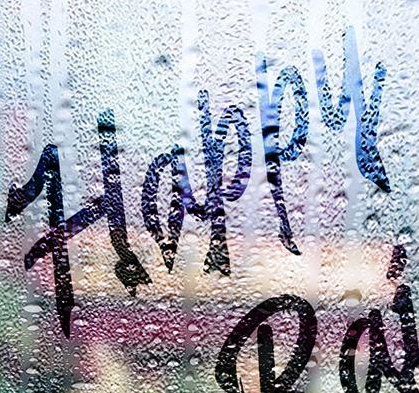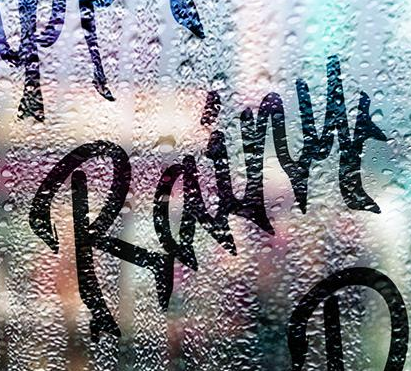Transcribe the words shown in these images in order, separated by a semicolon. Happy; Rainy 